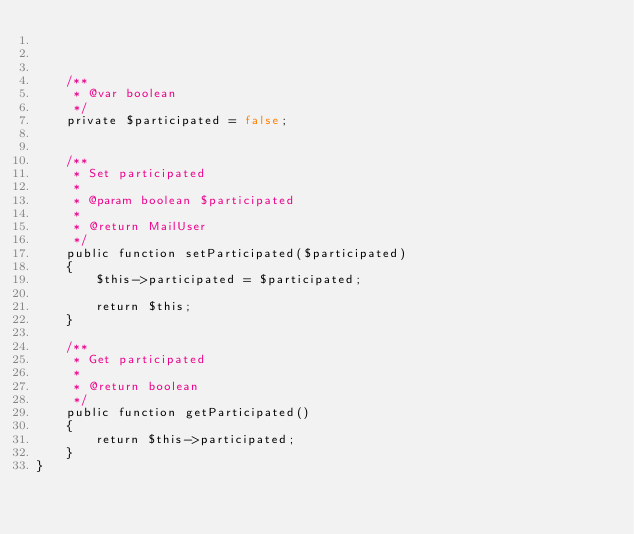Convert code to text. <code><loc_0><loc_0><loc_500><loc_500><_PHP_>
  
   
    /**
     * @var boolean
     */
    private $participated = false;
   

    /**
     * Set participated
     *
     * @param boolean $participated
     *
     * @return MailUser
     */
    public function setParticipated($participated)
    {
        $this->participated = $participated;

        return $this;
    }

    /**
     * Get participated
     *
     * @return boolean
     */
    public function getParticipated()
    {
        return $this->participated;
    }
}
</code> 